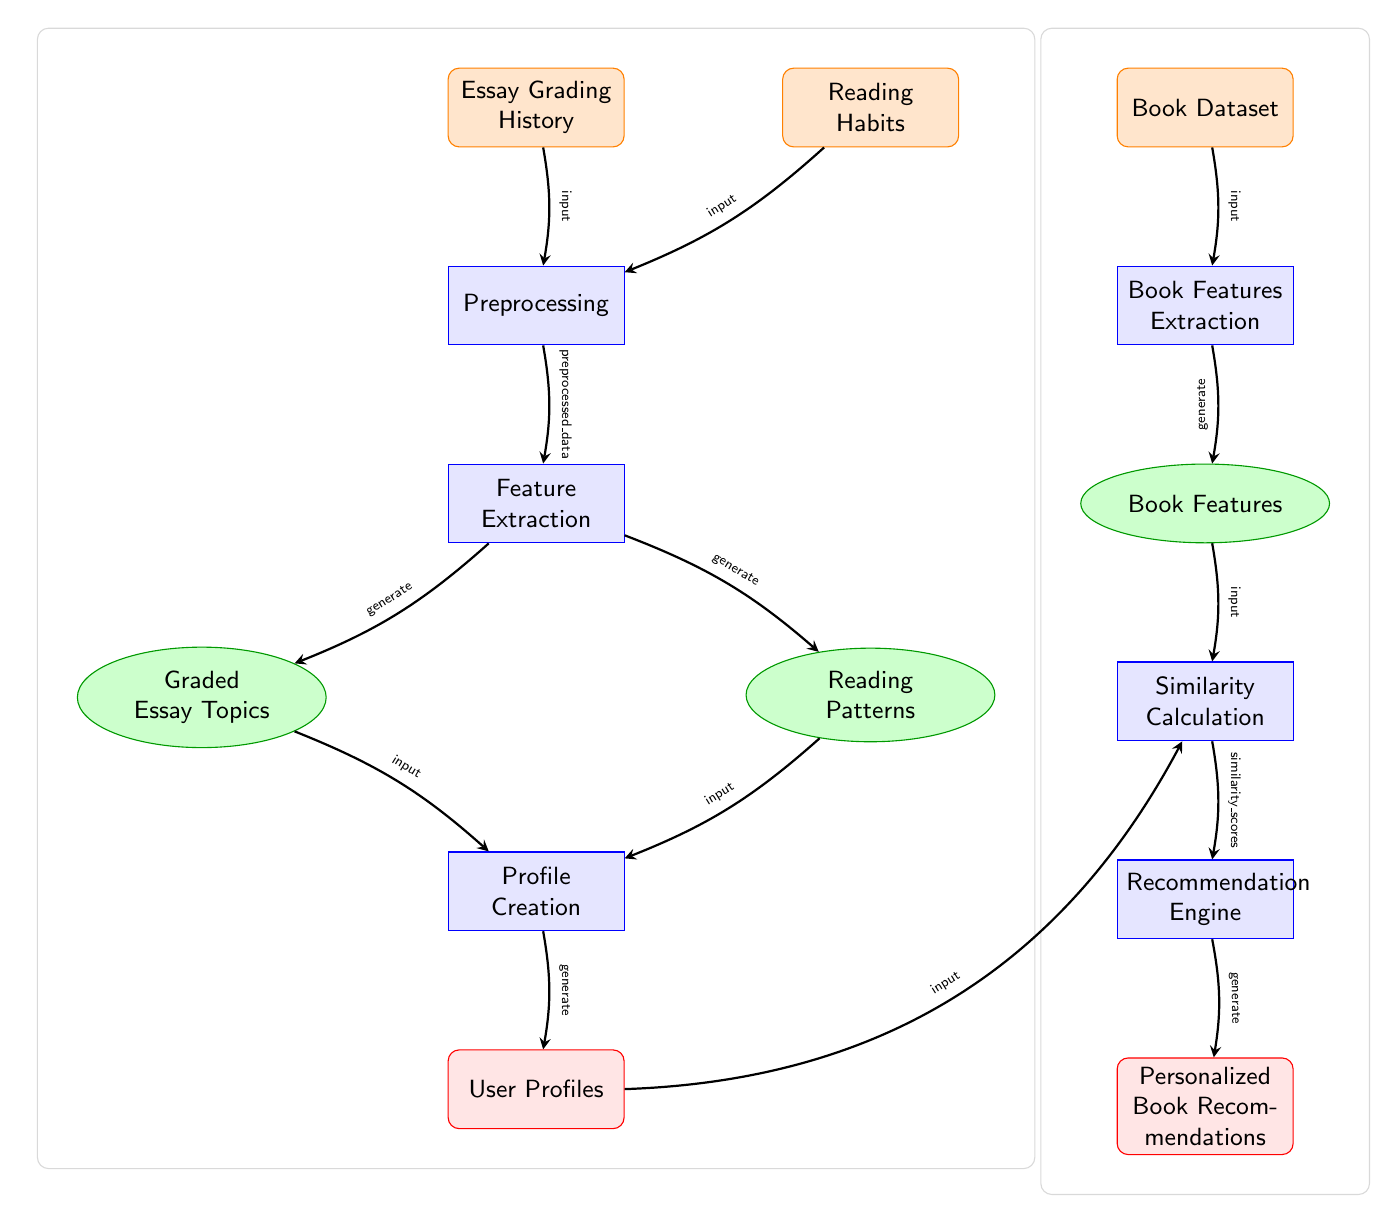What are the two inputs to the preprocessing step? The diagram shows two input nodes leading to the preprocessing step: "Essay Grading History" and "Reading Habits." These nodes are connected to the preprocessing rectangle with arrows indicating they are inputs.
Answer: Essay Grading History, Reading Habits How many features are extracted after preprocessing? The feature extraction step branches into two output nodes: "Graded Essay Topics" and "Reading Patterns." Thus, two features are extracted from the preprocessing stage.
Answer: 2 What is the output of the profile creation process? The profile creation process takes inputs from "Graded Essay Topics" and "Reading Patterns," and its output is "User Profiles," as indicated by the arrow leading to that node.
Answer: User Profiles What is the last step in generating personalized book recommendations? The last step is the "Personalized Book Recommendations," which is generated from the "Recommendation Engine" process. The recommendation engine receives input from the similarity calculation process, leading to the final output node.
Answer: Personalized Book Recommendations What type of data is required to initialize feature extraction? The feature extraction process requires preprocessed data from the previous step. The diagram indicates this with an arrow labeled "preprocessed_data" going into the feature extraction node.
Answer: Preprocessed data How does the "User Profiles" node connect to the recommendation process? The "User Profiles" node connects to the "Similarity Calculation" node, indicating that user profile information is input for the calculation of similarity scores, which inform the recommendation process.
Answer: Input How many major processes are involved in the diagram? The diagram includes several processes, specifically labeled as rectangles: "Preprocessing," "Feature Extraction," "Profile Creation," "Book Features Extraction," "Similarity Calculation," and "Recommendation Engine." This totals to six major processes.
Answer: 6 What is the main purpose of the book features extraction process? The book features extraction process aims to derive characteristics from the book dataset to assist in the recommendation process. This step is crucial for understanding how to correlate user preferences with book attributes.
Answer: To extract characteristics from books What are the final outputs of the diagram? The diagram indicates two outputs: "User Profiles" from the profile creation process and "Personalized Book Recommendations" from the recommendation engine, showing the ultimate outcomes of the entire flowchart.
Answer: User Profiles, Personalized Book Recommendations 